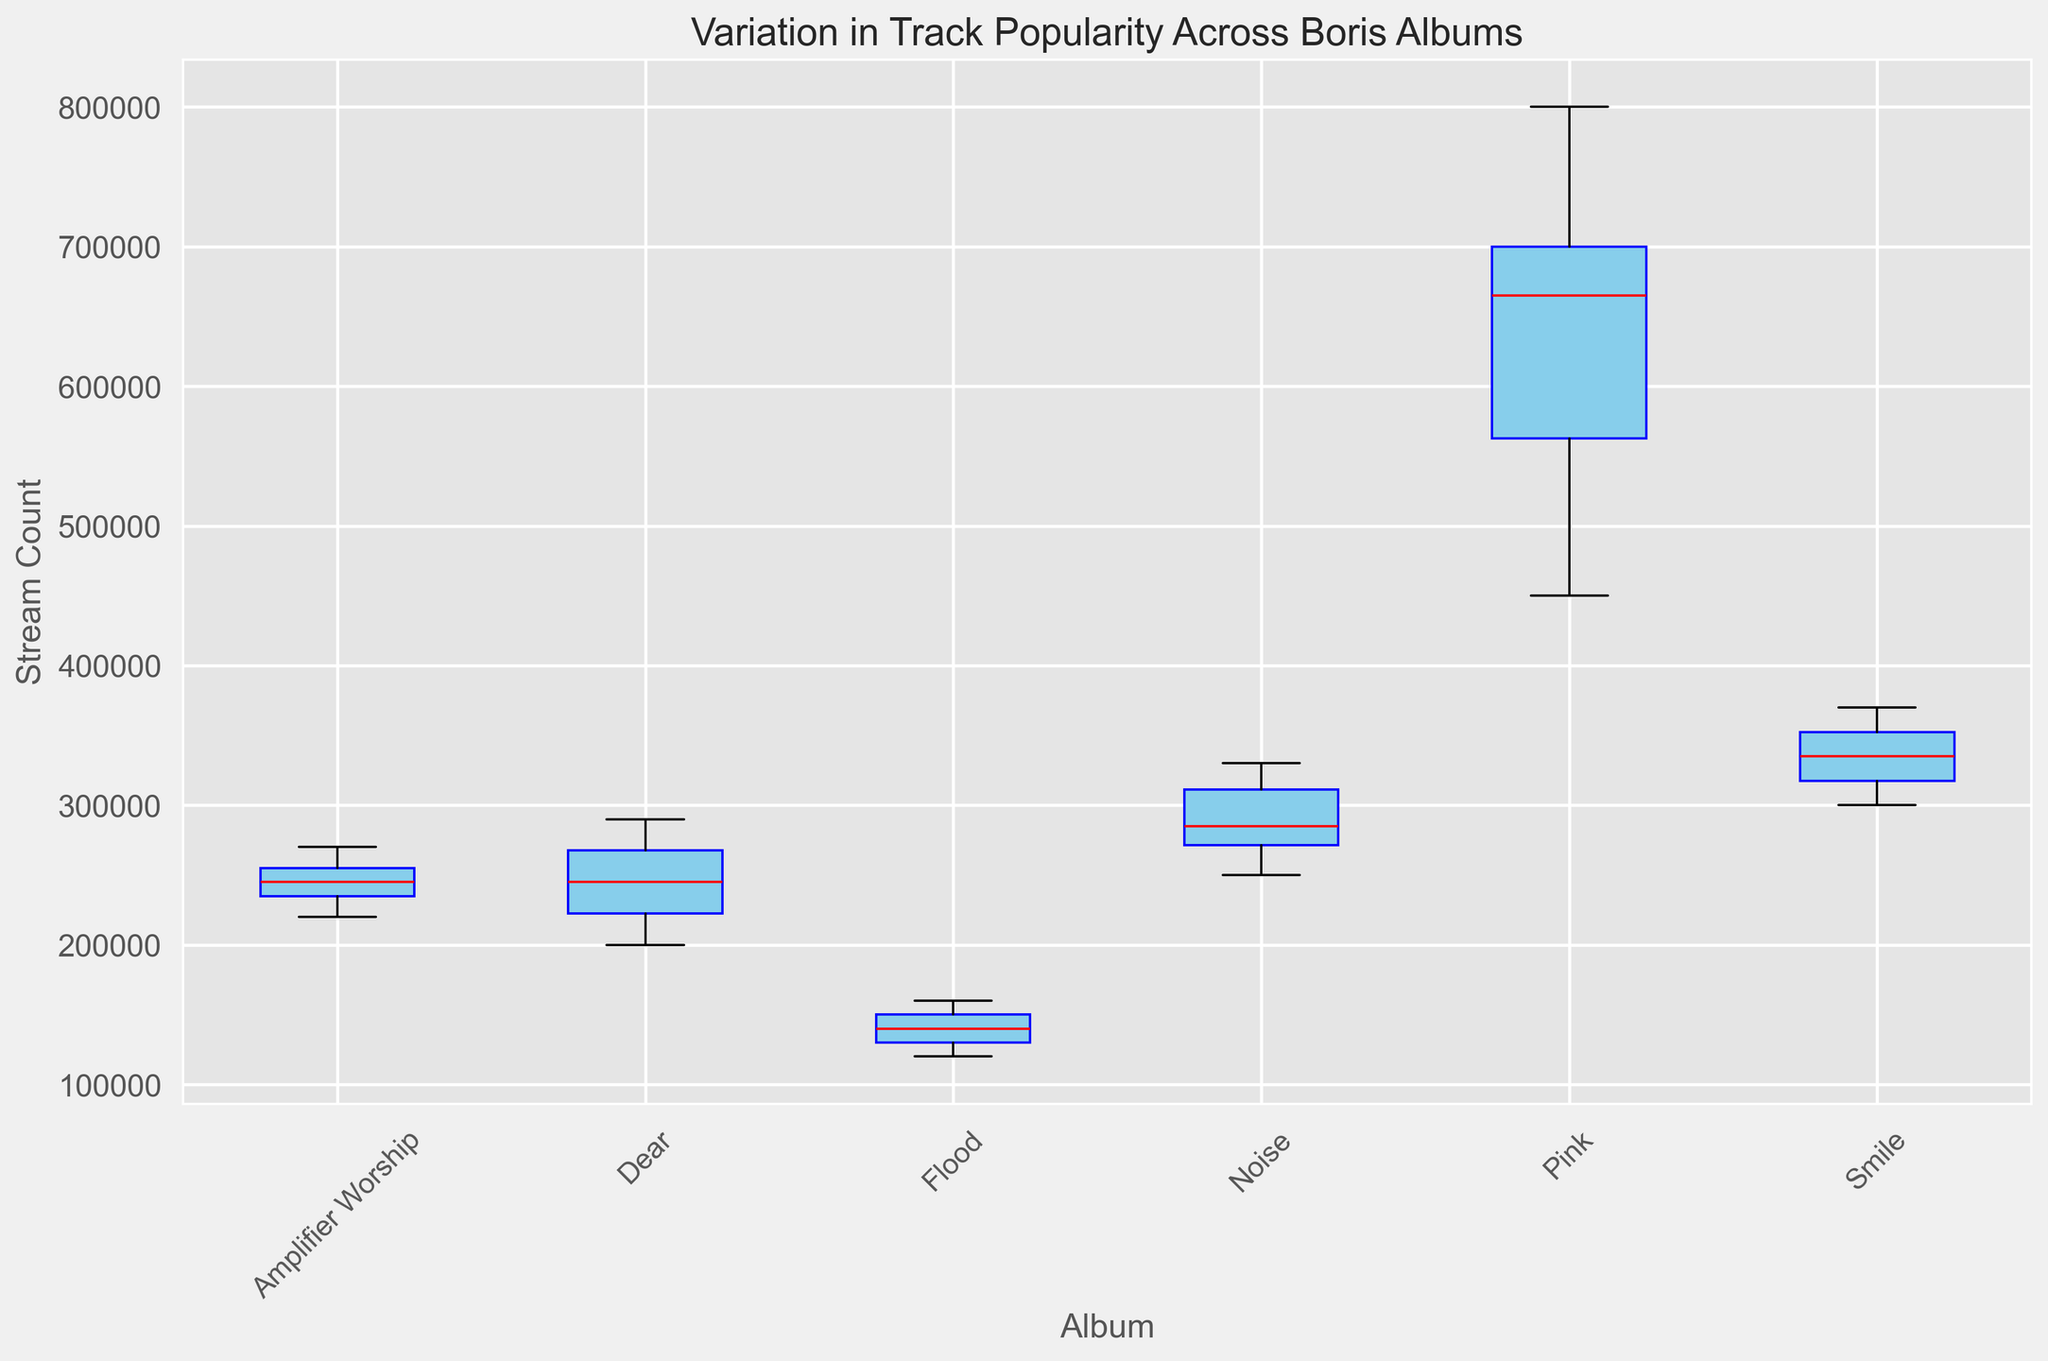Which album has the highest median stream count for its tracks? The median stream count for each album is represented by the red lines in the box plot. By visually comparing the heights of these median lines, it is evident which album has the highest median.
Answer: Pink Which album shows the largest variation in stream counts for its tracks? The variation in data is indicated by the height of the box and the length of the whiskers. Larger boxes and whiskers represent greater variation in stream counts.
Answer: Pink Between "Flood" and "Smile," which album has a higher maximum stream count for its tracks? To find which album has a higher maximum stream count, compare the upper whiskers (the lines extending from the boxes) of "Flood" and "Smile." The album with the higher upper whisker has the higher maximum stream count.
Answer: Smile What is the general trend in track popularity across the albums? The general trend can be understood by comparing the positions and sizes of the boxes and whiskers for each album. Albums with higher median lines and larger interquartile ranges indicate higher and more varied stream counts.
Answer: Pink has the highest and most varied popularity, followed by Smile, Noise, Amplifier Worship, and Flood For which album is the difference between the upper quartile and the median the smallest? The difference between the upper quartile and the median is represented by the upper half of the box. The album with the smallest upper half of the box has the smallest difference.
Answer: Dear How does the interquartile range (IQR) of "Noise" compare to that of "Amplifier Worship"? The IQR is represented by the height of the box. Comparing the heights of the boxes for "Noise" and "Amplifier Worship" will indicate which one is larger.
Answer: Noise Which album has the lowest minimum stream count? The minimum stream count is indicated by the bottom whisker of the box plot. The album with the lowest bottom whisker has the lowest minimum stream count.
Answer: Flood Is there any album where the stream counts for tracks are relatively consistent (low variation)? Consistency (low variation) is shown by small boxes and short whiskers in the box plot. The album with the smallest box and shortest whiskers has the most consistent stream counts.
Answer: Flood 